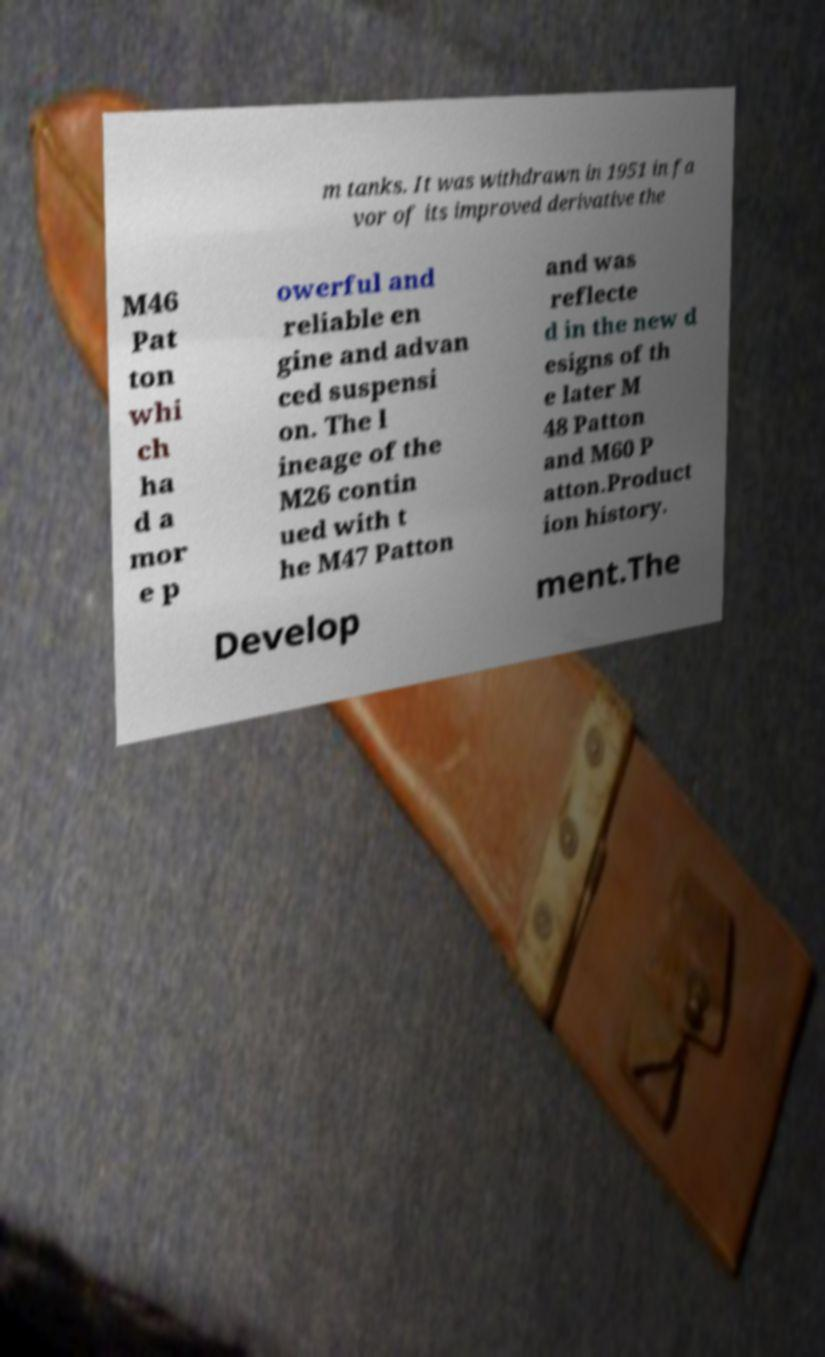What messages or text are displayed in this image? I need them in a readable, typed format. m tanks. It was withdrawn in 1951 in fa vor of its improved derivative the M46 Pat ton whi ch ha d a mor e p owerful and reliable en gine and advan ced suspensi on. The l ineage of the M26 contin ued with t he M47 Patton and was reflecte d in the new d esigns of th e later M 48 Patton and M60 P atton.Product ion history. Develop ment.The 